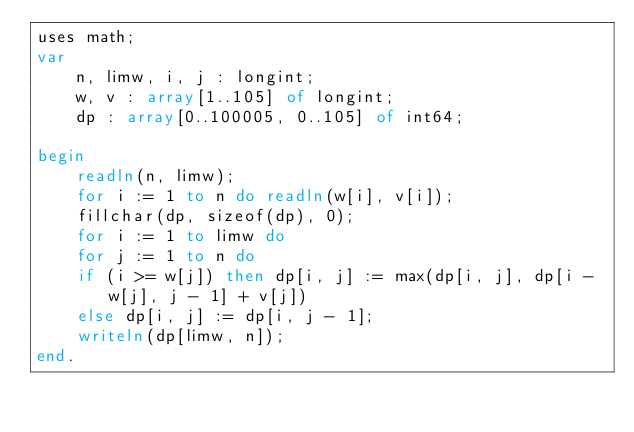<code> <loc_0><loc_0><loc_500><loc_500><_Pascal_>uses math;
var
    n, limw, i, j : longint;
    w, v : array[1..105] of longint;
    dp : array[0..100005, 0..105] of int64;

begin
    readln(n, limw);
    for i := 1 to n do readln(w[i], v[i]);
    fillchar(dp, sizeof(dp), 0); 
    for i := 1 to limw do
    for j := 1 to n do
    if (i >= w[j]) then dp[i, j] := max(dp[i, j], dp[i - w[j], j - 1] + v[j])
    else dp[i, j] := dp[i, j - 1];
    writeln(dp[limw, n]);
end.</code> 